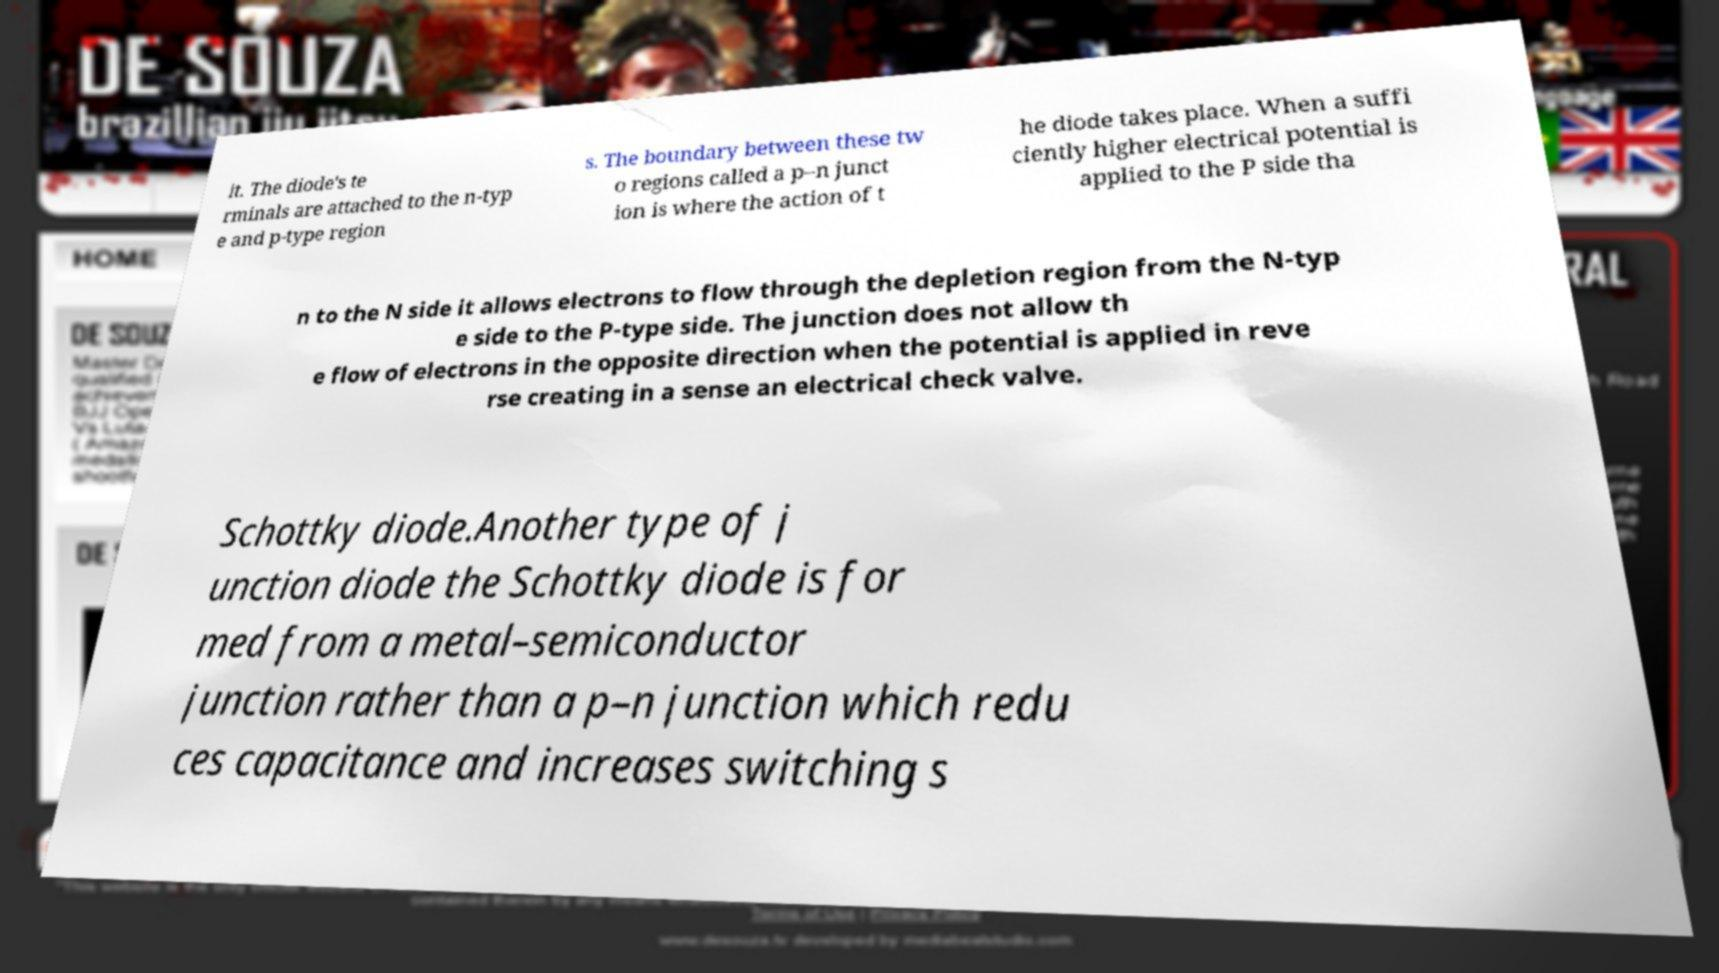Could you extract and type out the text from this image? it. The diode's te rminals are attached to the n-typ e and p-type region s. The boundary between these tw o regions called a p–n junct ion is where the action of t he diode takes place. When a suffi ciently higher electrical potential is applied to the P side tha n to the N side it allows electrons to flow through the depletion region from the N-typ e side to the P-type side. The junction does not allow th e flow of electrons in the opposite direction when the potential is applied in reve rse creating in a sense an electrical check valve. Schottky diode.Another type of j unction diode the Schottky diode is for med from a metal–semiconductor junction rather than a p–n junction which redu ces capacitance and increases switching s 